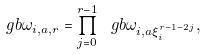Convert formula to latex. <formula><loc_0><loc_0><loc_500><loc_500>\ g b \omega _ { i , a , r } = \prod _ { j = 0 } ^ { r - 1 } \ g b \omega _ { i , a \xi _ { i } ^ { r - 1 - 2 j } } ,</formula> 